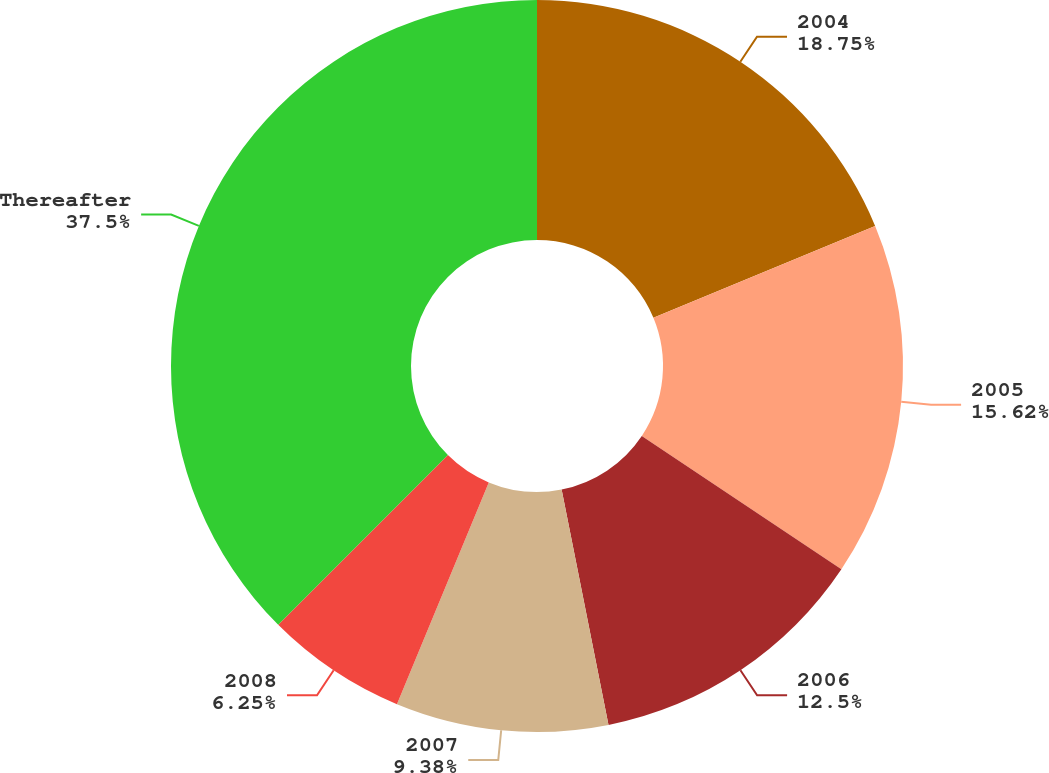Convert chart. <chart><loc_0><loc_0><loc_500><loc_500><pie_chart><fcel>2004<fcel>2005<fcel>2006<fcel>2007<fcel>2008<fcel>Thereafter<nl><fcel>18.75%<fcel>15.62%<fcel>12.5%<fcel>9.38%<fcel>6.25%<fcel>37.5%<nl></chart> 